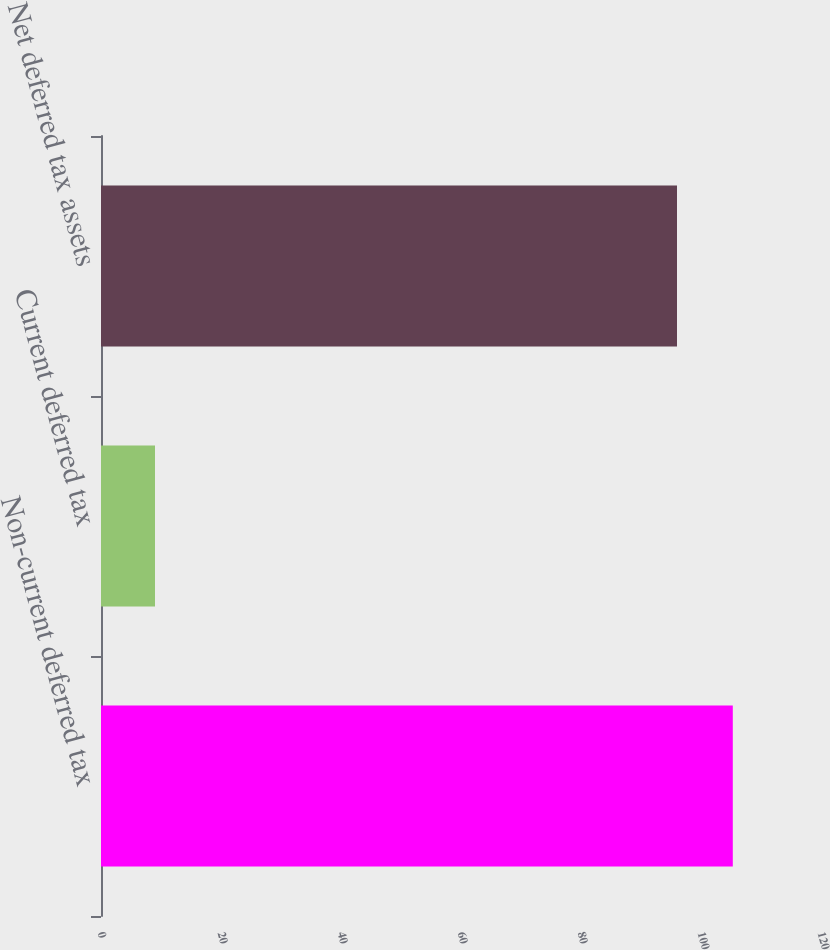Convert chart. <chart><loc_0><loc_0><loc_500><loc_500><bar_chart><fcel>Non-current deferred tax<fcel>Current deferred tax<fcel>Net deferred tax assets<nl><fcel>105.3<fcel>9<fcel>96<nl></chart> 